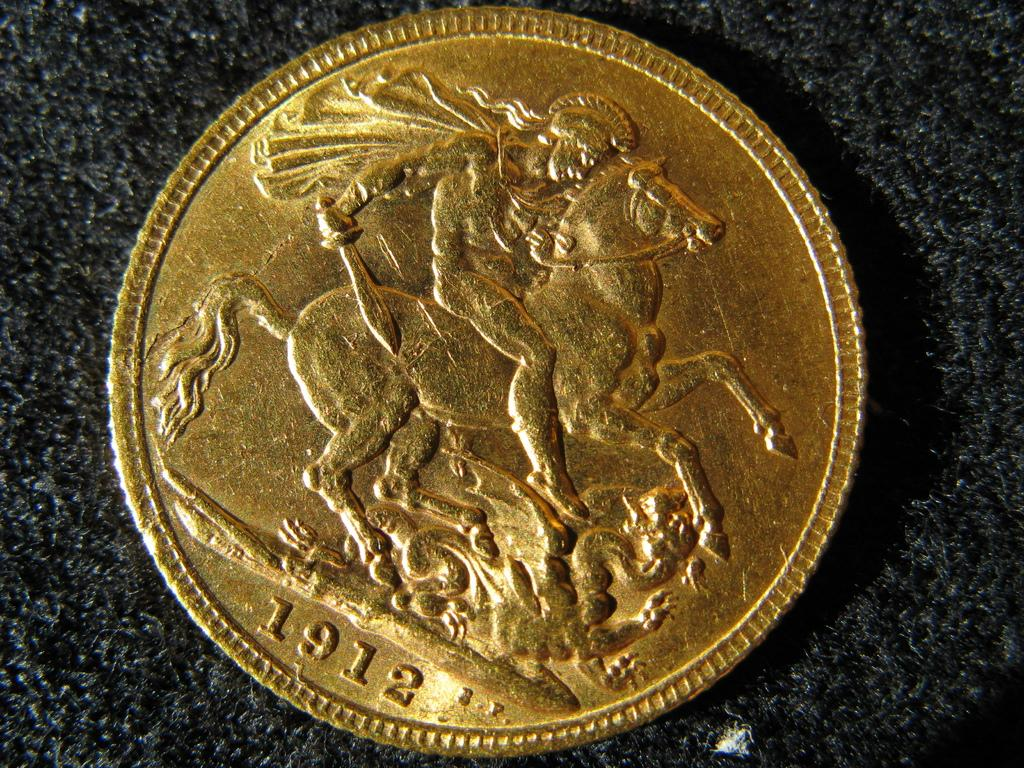<image>
Provide a brief description of the given image. A single gold coin with a man riding a horse and the year 1912 on it. 